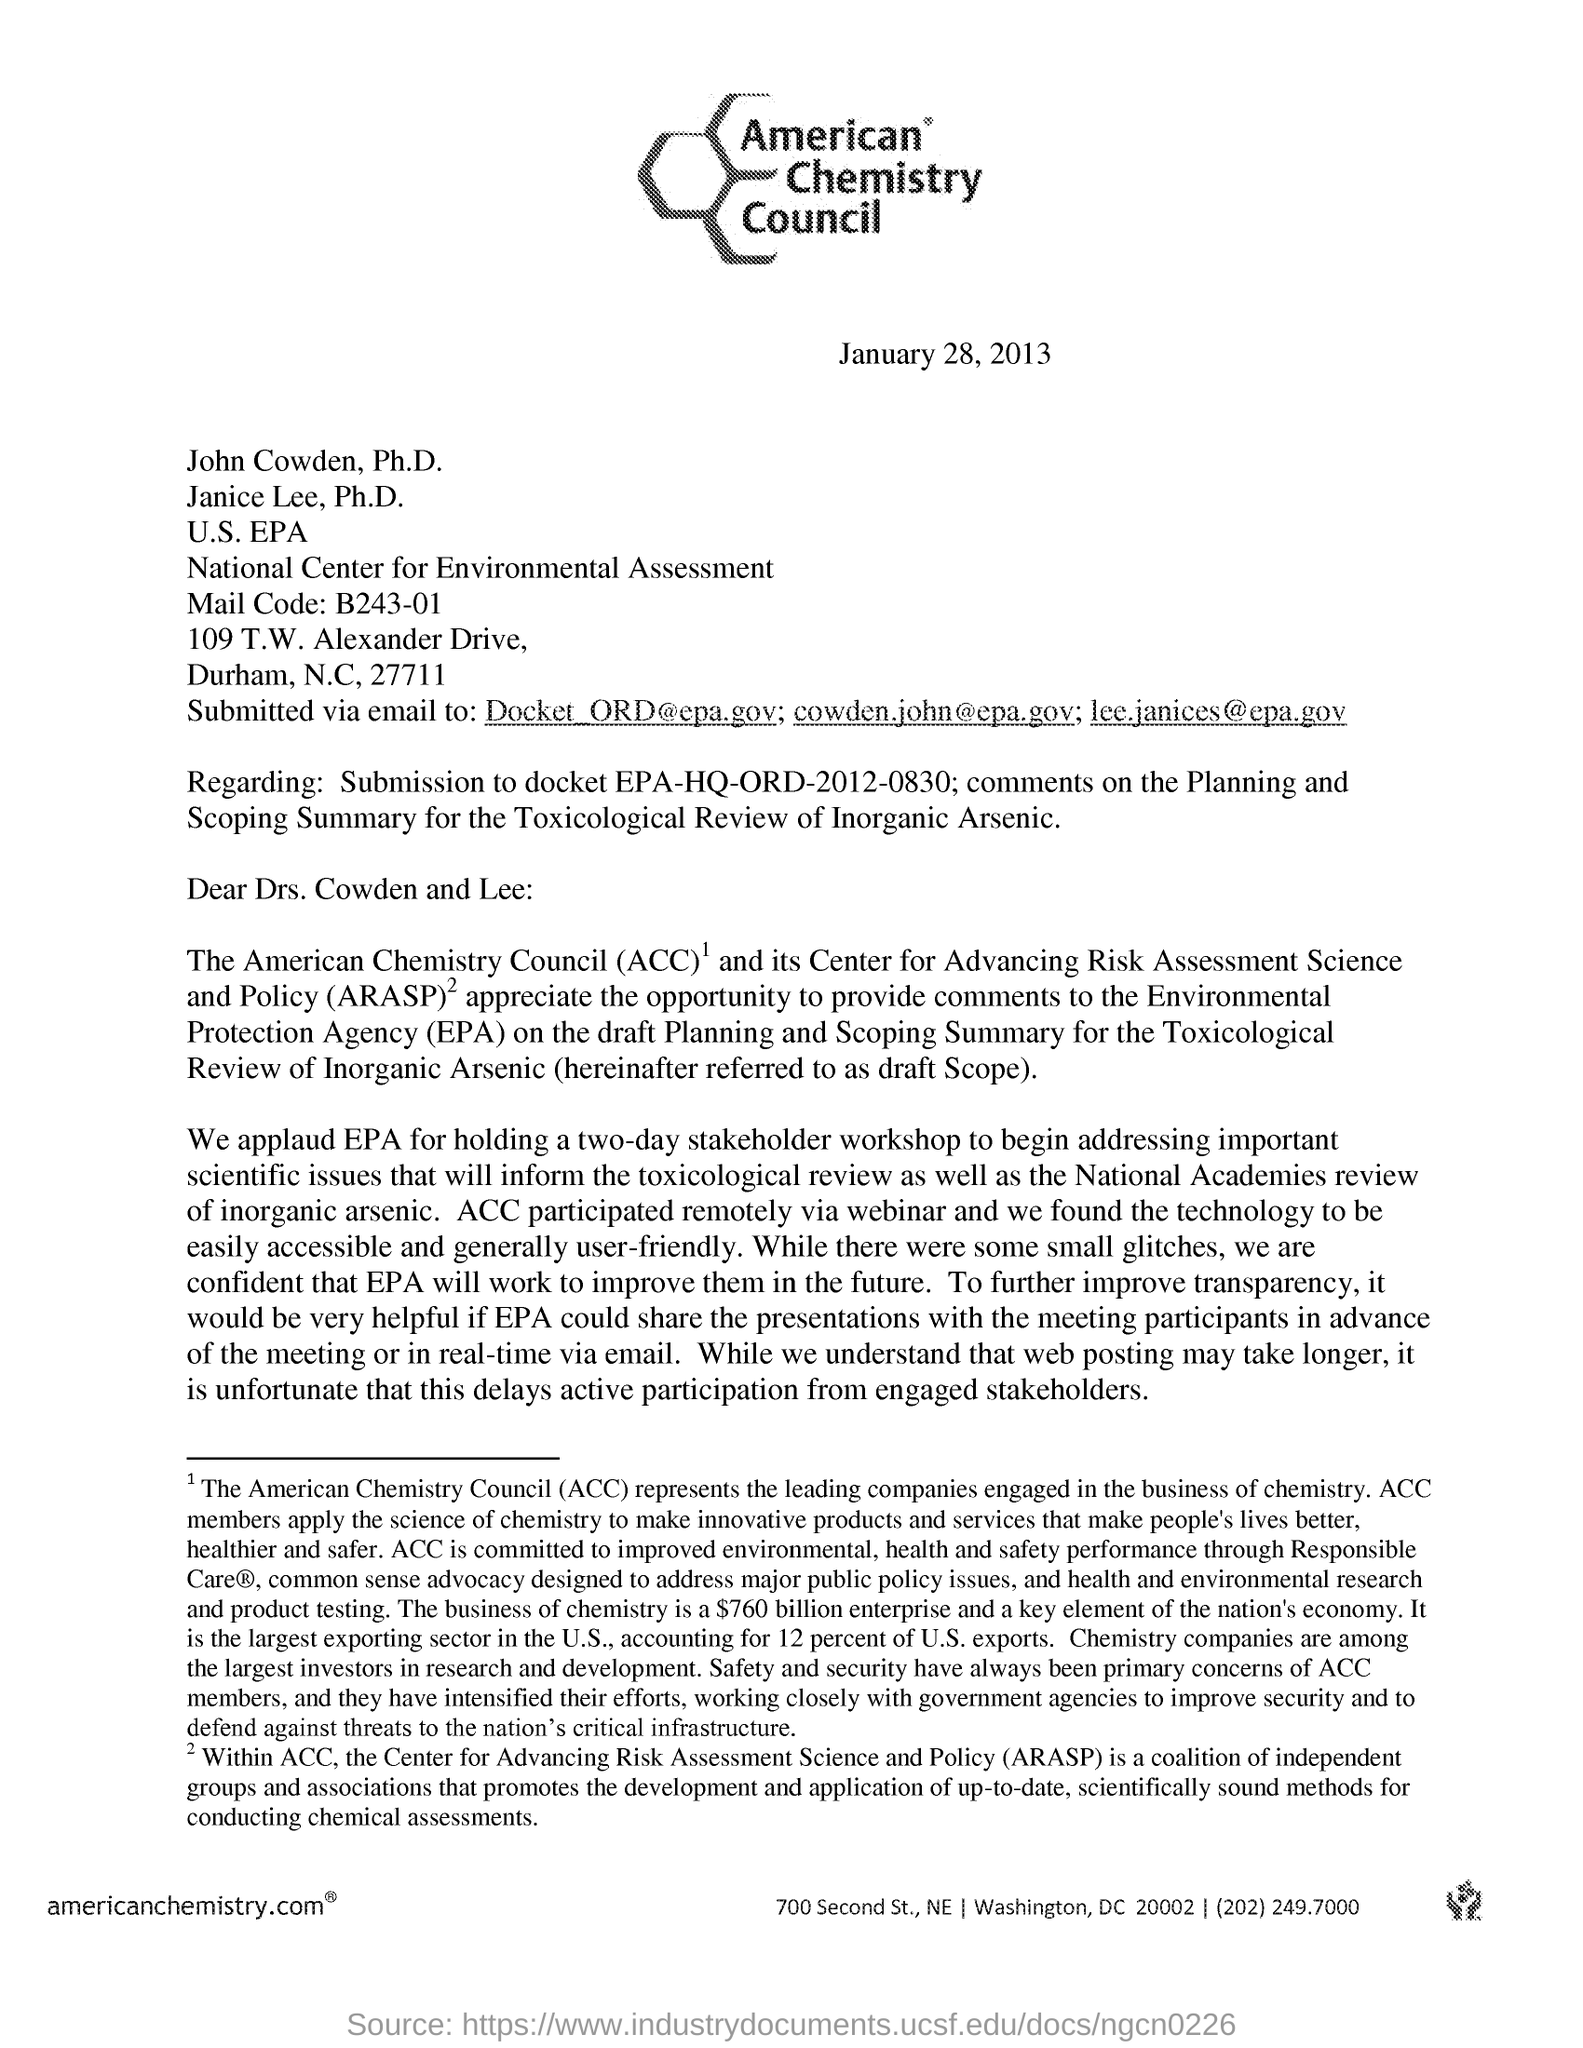What is the heading of the document?
Keep it short and to the point. American Chemistry council. What is the date mentioned?
Ensure brevity in your answer.  January 28, 2013. To whom is this email addressed?
Your answer should be compact. Docket_ORD@epa.gov; cowden.john@epa.gov; lee.janices@epagov. What is the full form ACC?
Ensure brevity in your answer.  American Chemistry Council. 